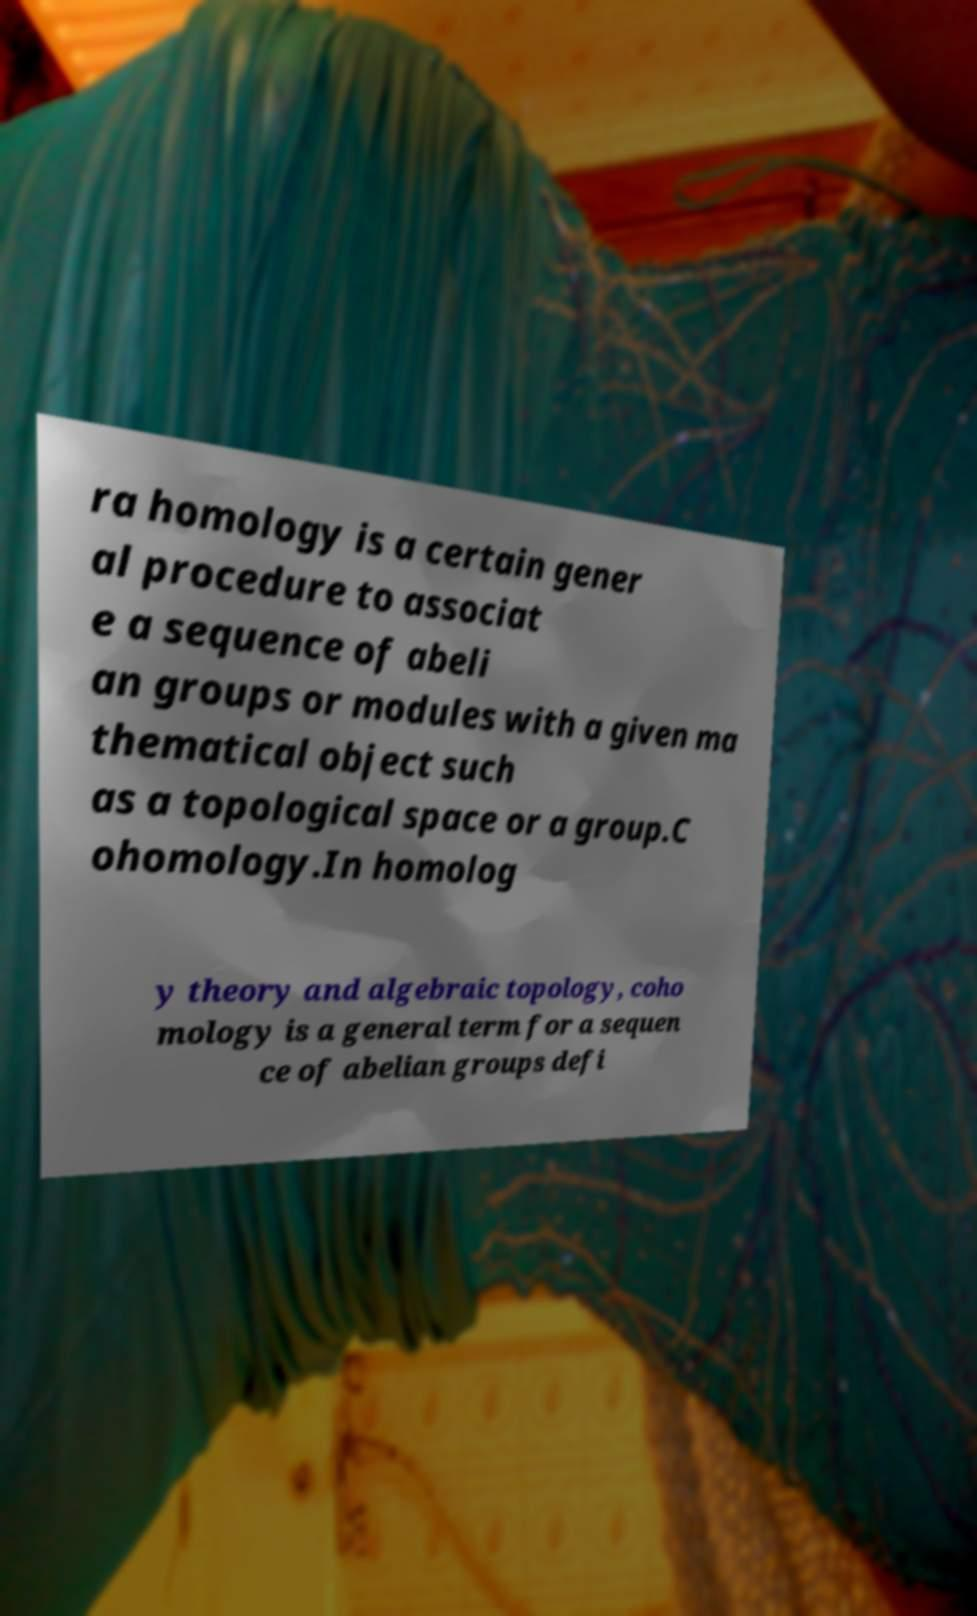Please identify and transcribe the text found in this image. ra homology is a certain gener al procedure to associat e a sequence of abeli an groups or modules with a given ma thematical object such as a topological space or a group.C ohomology.In homolog y theory and algebraic topology, coho mology is a general term for a sequen ce of abelian groups defi 